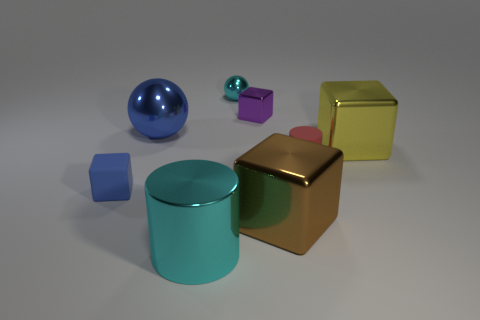There is a large cylinder that is the same color as the tiny ball; what is it made of?
Provide a succinct answer. Metal. There is a cyan metallic thing behind the yellow object; does it have the same size as the purple shiny block?
Provide a succinct answer. Yes. What color is the cube that is made of the same material as the tiny red cylinder?
Offer a terse response. Blue. Are there any other things that are the same size as the brown shiny block?
Offer a very short reply. Yes. There is a purple block; what number of tiny purple blocks are behind it?
Ensure brevity in your answer.  0. There is a rubber object that is to the right of the small blue cube; is its color the same as the object in front of the big brown cube?
Provide a succinct answer. No. What color is the other thing that is the same shape as the red rubber object?
Provide a short and direct response. Cyan. Are there any other things that are the same shape as the tiny red object?
Give a very brief answer. Yes. Do the matte object to the right of the large brown shiny cube and the blue thing that is in front of the yellow block have the same shape?
Make the answer very short. No. Do the blue cube and the cyan metallic object that is in front of the blue sphere have the same size?
Offer a terse response. No. 